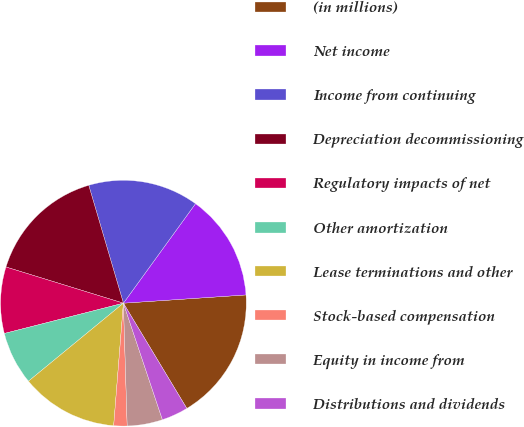Convert chart to OTSL. <chart><loc_0><loc_0><loc_500><loc_500><pie_chart><fcel>(in millions)<fcel>Net income<fcel>Income from continuing<fcel>Depreciation decommissioning<fcel>Regulatory impacts of net<fcel>Other amortization<fcel>Lease terminations and other<fcel>Stock-based compensation<fcel>Equity in income from<fcel>Distributions and dividends<nl><fcel>17.44%<fcel>13.95%<fcel>14.53%<fcel>15.69%<fcel>8.72%<fcel>6.98%<fcel>12.79%<fcel>1.75%<fcel>4.65%<fcel>3.49%<nl></chart> 